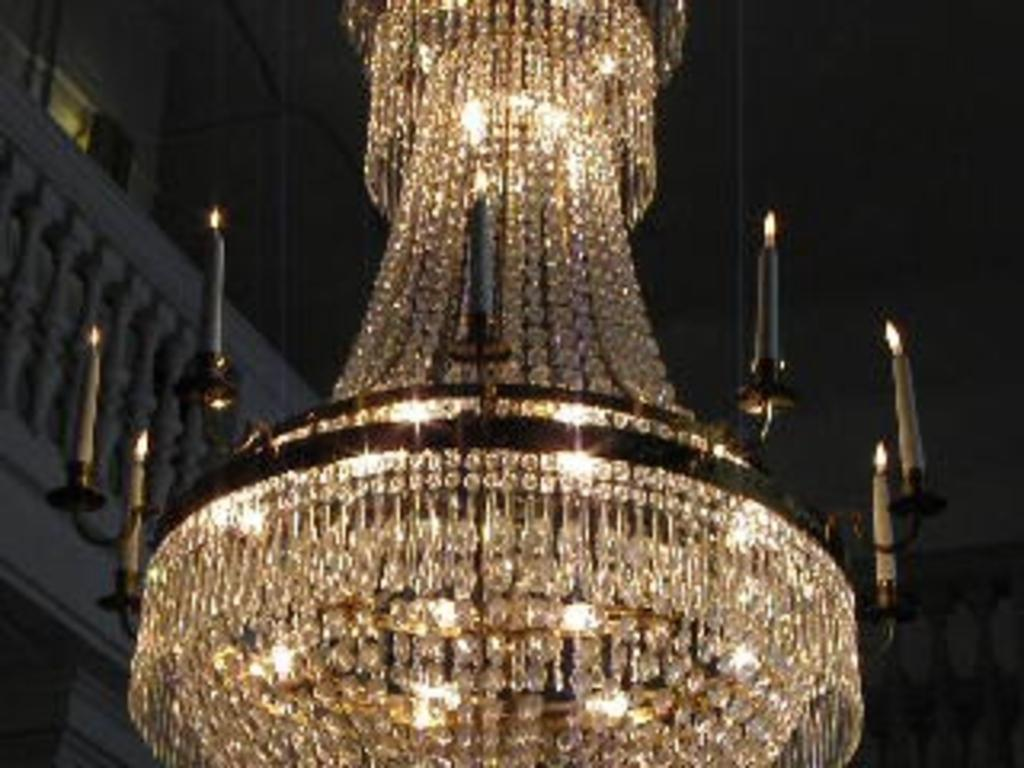What type of illumination source is present in the image? There is a light in the image. What can be seen as an alternative source of light in the image? There are candles in the image. What type of structure is visible in the image? There is a wall in the image. What type of barrier is visible in the image? There is a fence in the image. How many dimes are stacked on top of the candles in the image? There are no dimes present in the image. What type of fruit is being crushed by the light in the image? There is no fruit, and the light is not crushing anything in the image. 